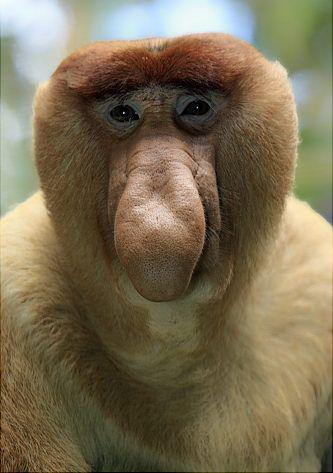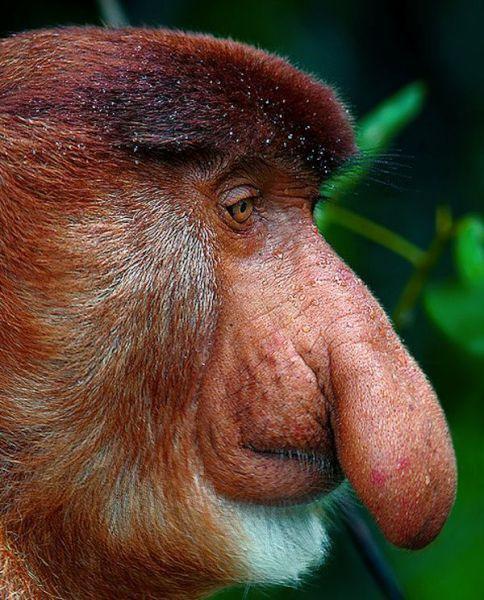The first image is the image on the left, the second image is the image on the right. For the images displayed, is the sentence "There is more than one monkey in the left image." factually correct? Answer yes or no. No. The first image is the image on the left, the second image is the image on the right. Considering the images on both sides, is "At least one of the animals is showing its teeth." valid? Answer yes or no. No. 